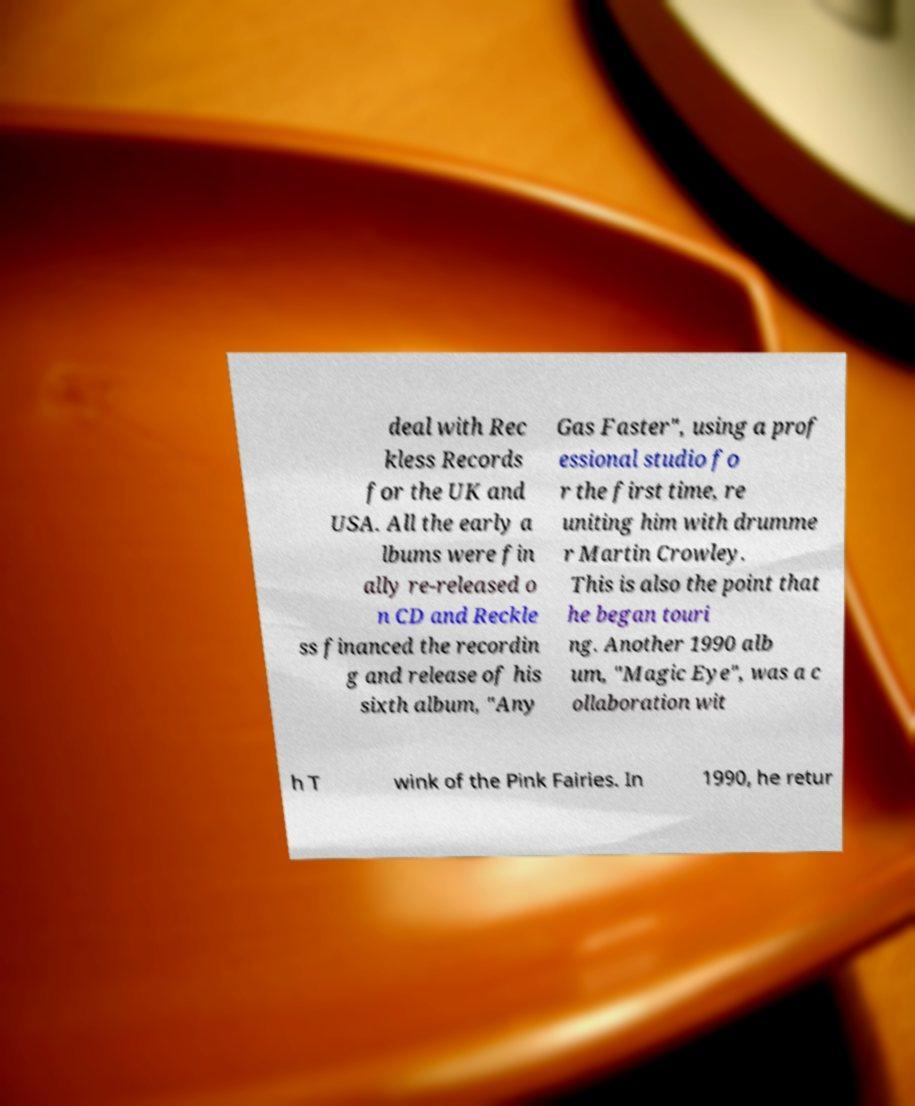Could you assist in decoding the text presented in this image and type it out clearly? deal with Rec kless Records for the UK and USA. All the early a lbums were fin ally re-released o n CD and Reckle ss financed the recordin g and release of his sixth album, "Any Gas Faster", using a prof essional studio fo r the first time, re uniting him with drumme r Martin Crowley. This is also the point that he began touri ng. Another 1990 alb um, "Magic Eye", was a c ollaboration wit h T wink of the Pink Fairies. In 1990, he retur 